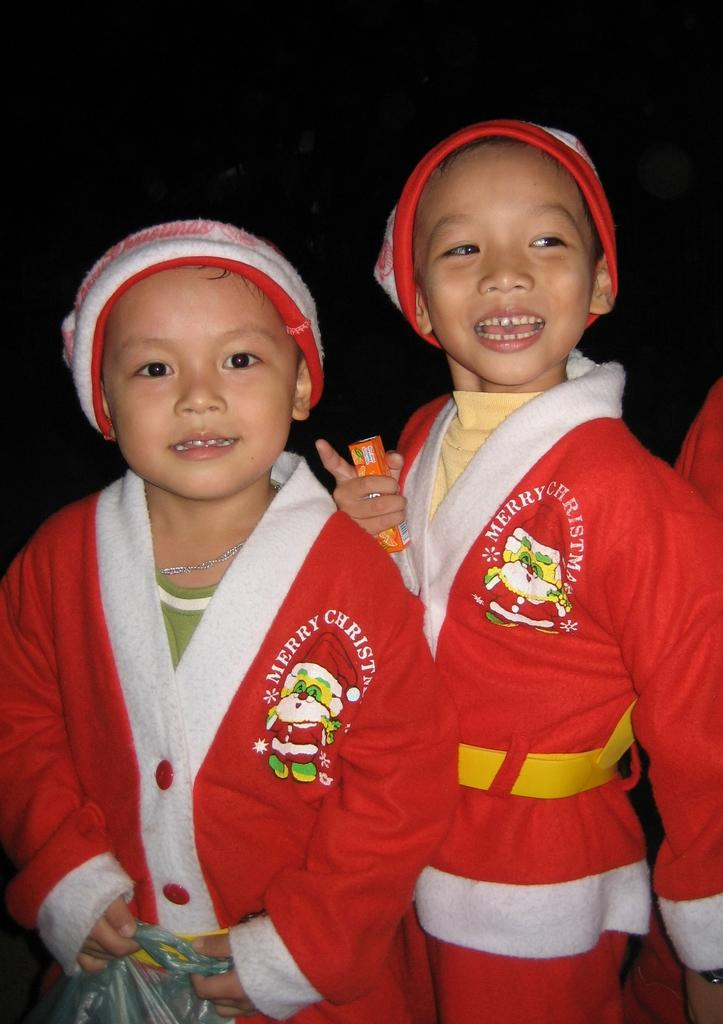Provide a one-sentence caption for the provided image. two little kids wear santa outfits that say Merry Christmas. 